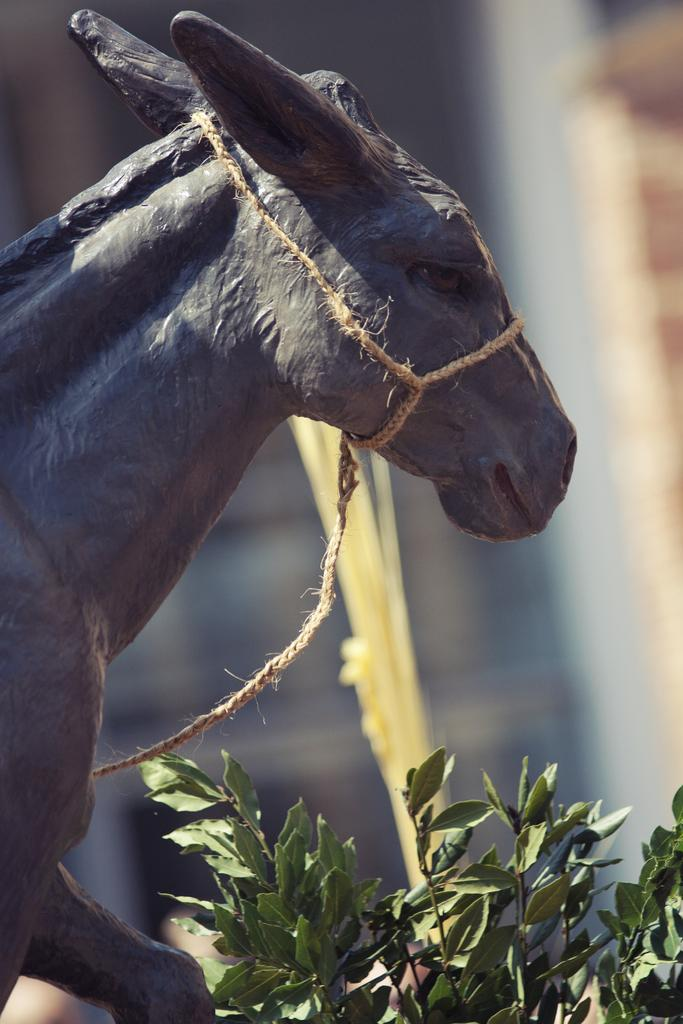What is the main subject of the image? There is a statue of an animal in the image. How is the statue secured or positioned? The statue is tied with a rope. What type of vegetation is present at the bottom of the image? There are plants at the bottom of the image. Can you describe the fight between the cars in the hall that is visible in the image? There is no fight between cars or any hall present in the image; it features a statue of an animal tied with a rope and plants at the bottom. 